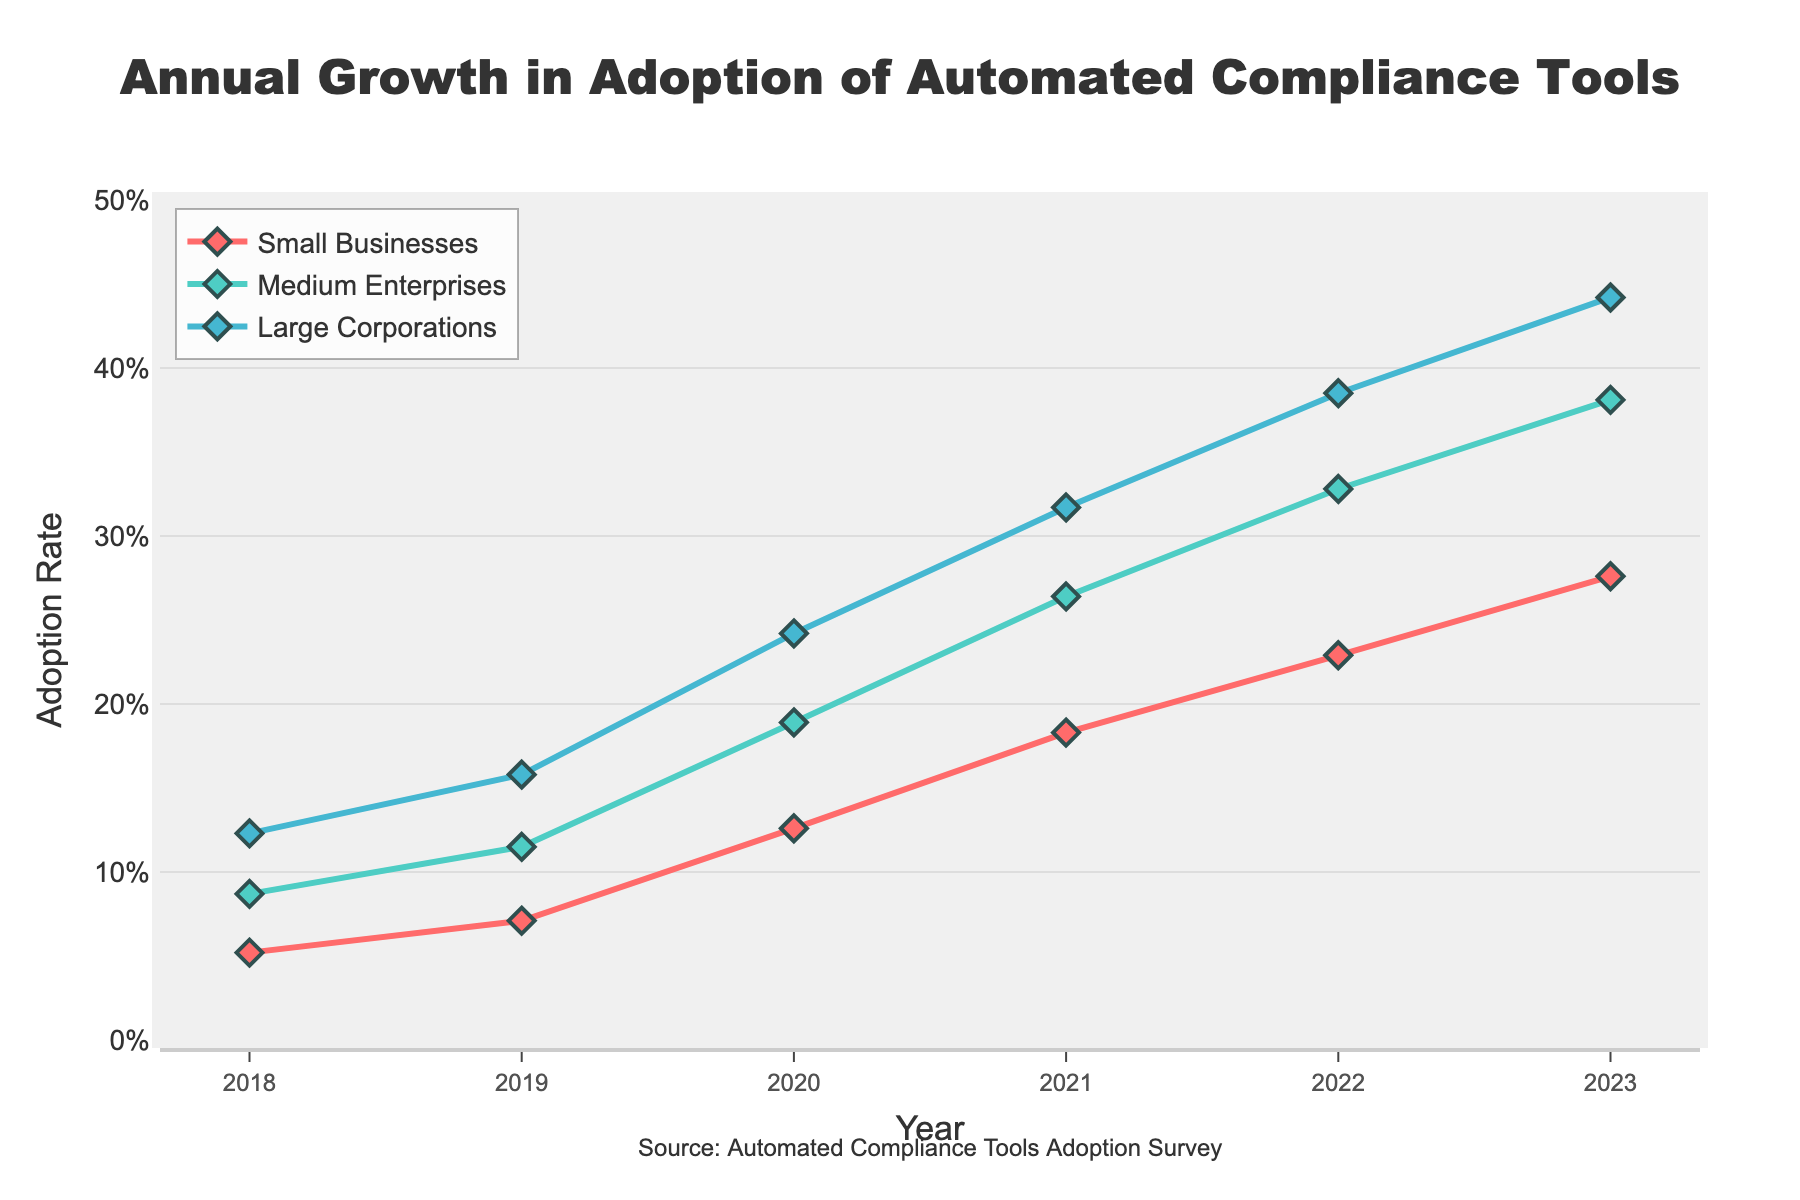What is the trend in the adoption rate of automated compliance tools for small businesses from 2018 to 2023? The adoption rate for small businesses shows a consistent increase every year from 5.2% in 2018 to 27.6% in 2023.
Answer: Consistent annual increase Which business size had the highest adoption rate in 2023? In 2023, the adoption rate for large corporations was the highest at 44.2%, compared to 27.6% for small businesses and 38.1% for medium enterprises.
Answer: Large Corporations How much did the adoption rate for medium enterprises grow from 2018 to 2023? The adoption rate for medium enterprises increased from 8.7% in 2018 to 38.1% in 2023. To find the growth, subtract 8.7% from 38.1% which results in a growth of 29.4%.
Answer: 29.4% In which year did large corporations have an adoption rate greater than 30% for the first time? The adoption rate for large corporations exceeded 30% for the first time in 2021, when it reached 31.7%.
Answer: 2021 By how much did the adoption rate for small businesses increase from 2019 to 2020? The adoption rate for small businesses increased from 7.1% in 2019 to 12.6% in 2020. Subtract 7.1% from 12.6%, resulting in an increase of 5.5%.
Answer: 5.5% Compare the adoption rates of small businesses and large corporations in 2020. Which is higher and by how much? In 2020, the adoption rate for small businesses was 12.6%, while for large corporations, it was 24.2%. Subtract 12.6% from 24.2% to determine the difference, which is 11.6%.
Answer: Large corporations by 11.6% What was the average adoption rate of automated compliance tools for medium enterprises between 2018 and 2023? The adoption rates for medium enterprises over the years are 8.7%, 11.5%, 18.9%, 26.4%, 32.8%, and 38.1%. Sum these values: 8.7 + 11.5 + 18.9 + 26.4 + 32.8 + 38.1 = 136.4. Divide by the number of years (6) to find the average: 136.4 / 6 ≈ 22.73%.
Answer: 22.73% Between medium enterprises and large corporations, which group had a higher increase in adoption rate from 2019 to 2022? For medium enterprises, the adoption rates were 11.5% in 2019 and 32.8% in 2022. The increase is 32.8% - 11.5% = 21.3%. For large corporations, the adoption rates were 15.8% in 2019 and 38.5% in 2022. The increase is 38.5% - 15.8% = 22.7%. Large corporations had a higher increase.
Answer: Large corporations By how much did the adoption rate of large corporations exceed that of small businesses in 2021? In 2021, the adoption rate for large corporations was 31.7% and for small businesses, it was 18.3%. Subtract 18.3% from 31.7%, resulting in an excess of 13.4%.
Answer: 13.4% What is the color used for the line representing small businesses? The line representing small businesses is colored red.
Answer: Red 